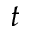Convert formula to latex. <formula><loc_0><loc_0><loc_500><loc_500>t</formula> 